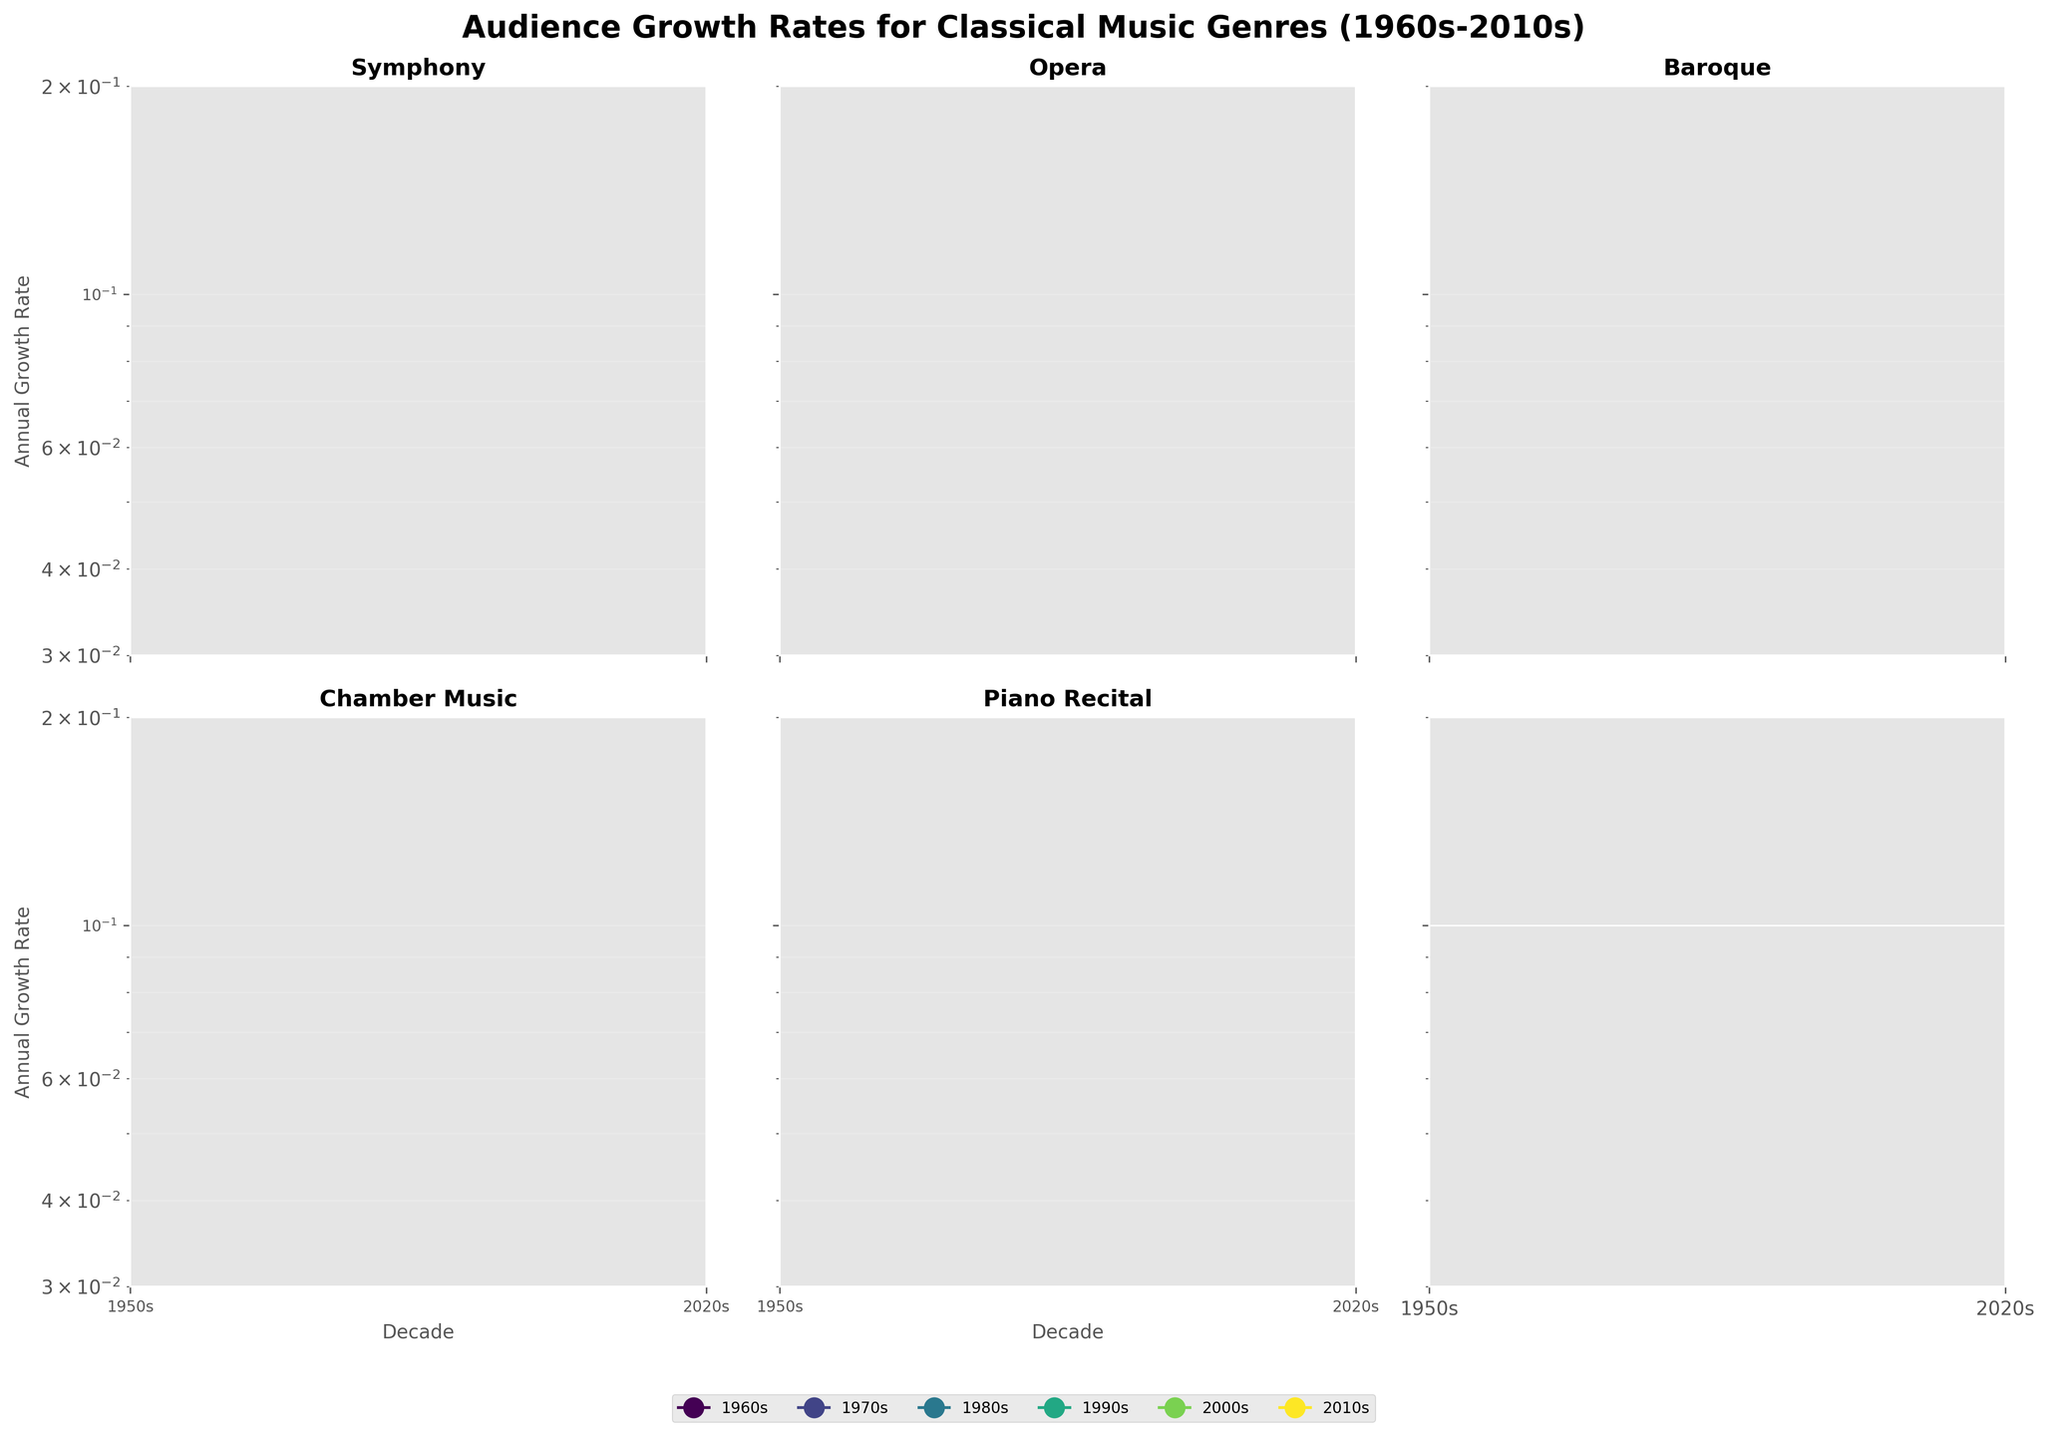What is the title of the figure? The title of the figure is usually written at the top and gives an overview of what the figure is about. In this case, it is "Audience Growth Rates for Classical Music Genres (1960s-2010s)" as specified.
Answer: Audience Growth Rates for Classical Music Genres (1960s-2010s) Which genre shows the highest annual growth rate in the 1960s? From the plot, we look at the individual subplots and locate the year 1960s on each genre. We see that Opera has the highest growth rate for the 1960s.
Answer: Opera How does the annual growth rate for Symphony change from the 1960s to the 2010s? By examining the data points for Symphony from the 1960s to the 2010s, the annual growth rate decreases. We see the values drop steadily from 0.12 to 0.05.
Answer: Decreases steadily What is the difference in the annual growth rate between Baroque and Chamber Music in the 1970s? Find the values for Baroque and Chamber Music in the 1970s. Baroque is 0.09 and Chamber Music is 0.08. The difference is 0.09 - 0.08.
Answer: 0.01 Which genre had the smallest decline in annual growth rate from the 1960s to the 2010s? To determine the smallest decline, subtract each genre's 2010s value from its 1960s value. The smallest difference indicates the smallest decline. Chamber Music had the smallest decline (0.09 to 0.04).
Answer: Chamber Music Which genre experienced the greatest overall decline in annual growth rate from the 1960s to the 2010s? To find the genre with the greatest overall decline, subtract the 2010s growth rate from the 1960s growth rate for each genre. The greatest difference shows the greatest decline. Opera had the greatest decline (0.14 to 0.07).
Answer: Opera If the trends continue, which genre would you predict to have the lowest growth rate in the 2020s? Looking at the trends, we see the direction and magnitude of change. Chamber Music is the genre experiencing the sharpest continual decline, leading to it likely having the lowest rate in the 2020s.
Answer: Chamber Music Arrange the genres in descending order of their annual growth rate in the 2000s. To display this, we check the values for all genres in the 2000s: Symphony (0.06), Opera (0.09), Baroque (0.06), Chamber Music (0.05), Piano Recital (0.07). Then, order them from highest to lowest.
Answer: Opera, Piano Recital, Symphony/Baroque, Chamber Music What is the range of annual growth rates for genres in the 2010s? To find the range, determine the maximum and minimum growth rates in the 2010s across all genres. The range is the difference between the highest and lowest values. Highest is Opera (0.07) and lowest is Chamber Music (0.04).
Answer: 0.03 